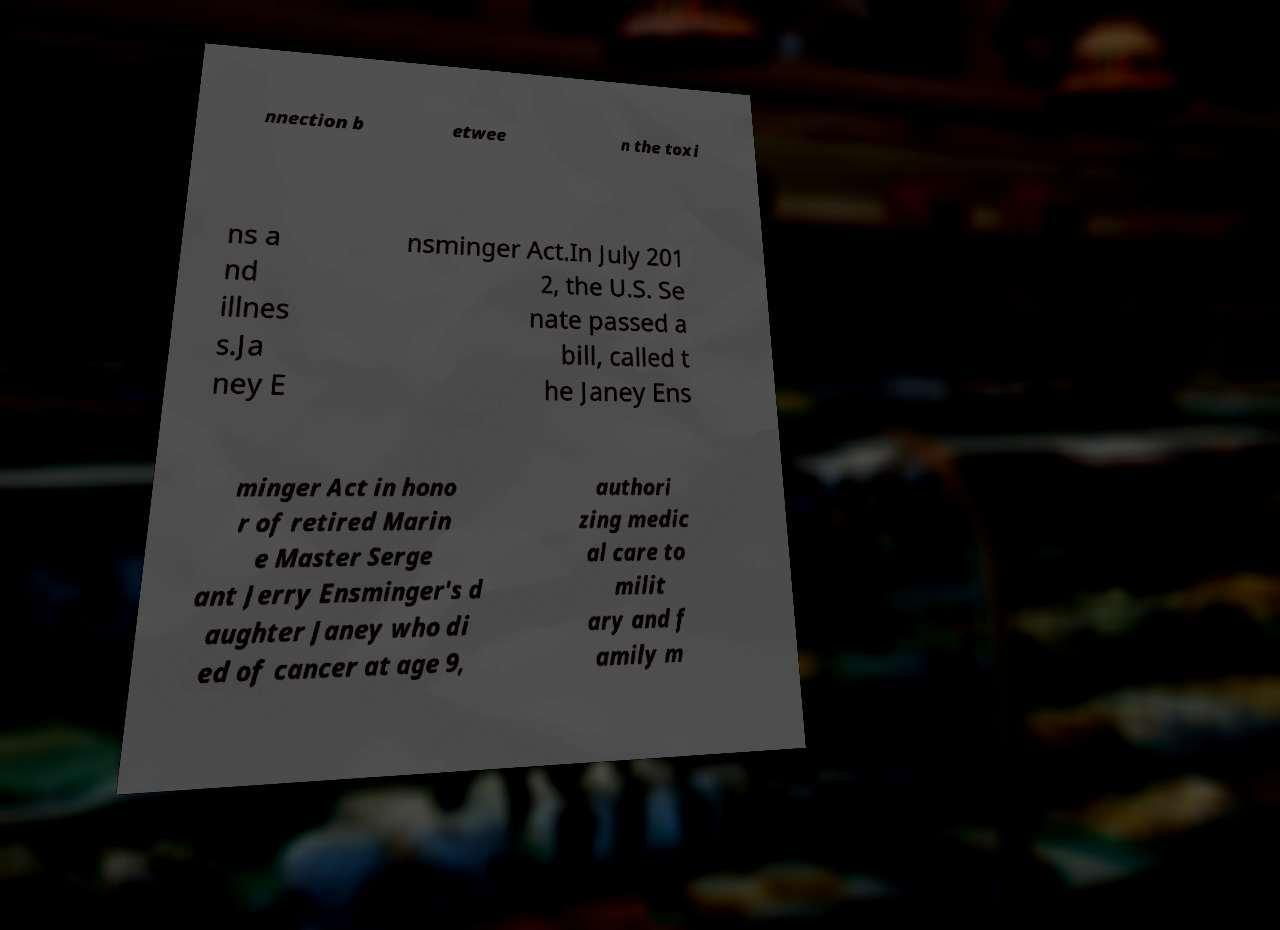Could you assist in decoding the text presented in this image and type it out clearly? nnection b etwee n the toxi ns a nd illnes s.Ja ney E nsminger Act.In July 201 2, the U.S. Se nate passed a bill, called t he Janey Ens minger Act in hono r of retired Marin e Master Serge ant Jerry Ensminger's d aughter Janey who di ed of cancer at age 9, authori zing medic al care to milit ary and f amily m 